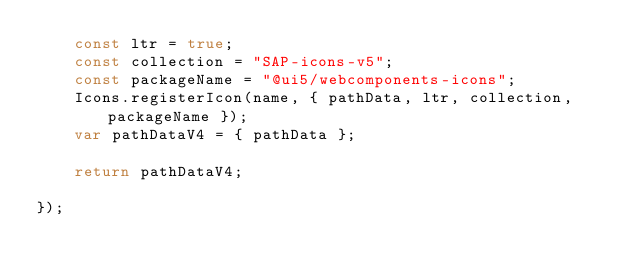<code> <loc_0><loc_0><loc_500><loc_500><_JavaScript_>	const ltr = true;
	const collection = "SAP-icons-v5";
	const packageName = "@ui5/webcomponents-icons";
	Icons.registerIcon(name, { pathData, ltr, collection, packageName });
	var pathDataV4 = { pathData };

	return pathDataV4;

});
</code> 